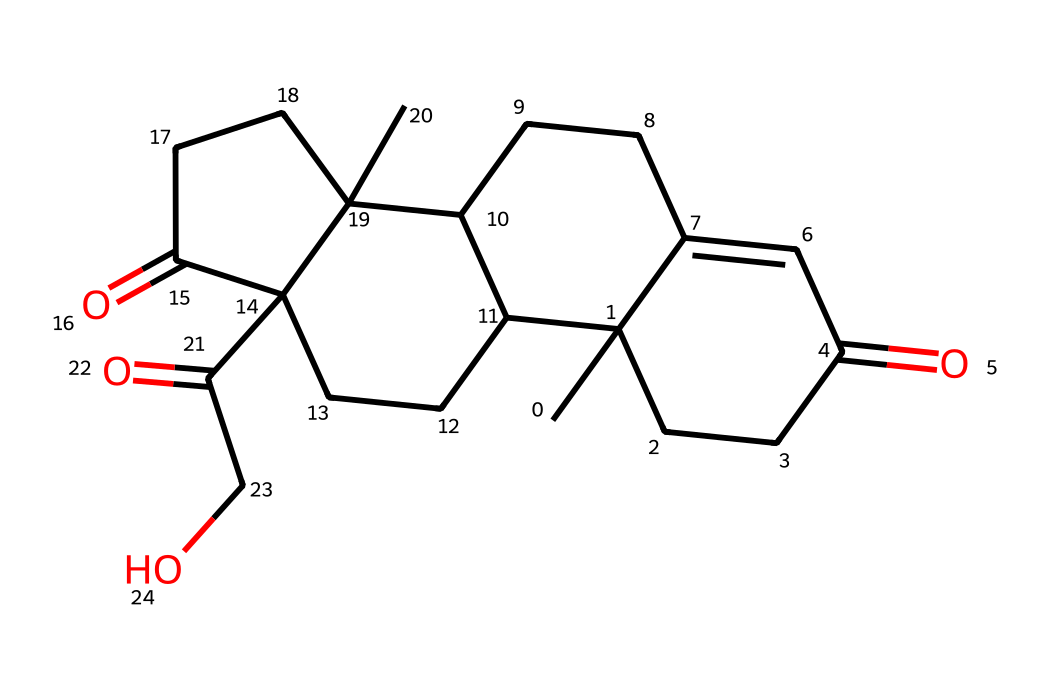How many carbon atoms are in cortisol? By analyzing the SMILES representation, we can count the number of carbon atoms by identifying the 'C' symbols. In this case, there are 21 carbon atoms.
Answer: 21 What is the functional group present in cortisol? Looking at the structure, we see that cortisol contains ketone groups, indicated by the C(=O) notation, as well as a hydroxyl group (–OH).
Answer: ketone, hydroxyl What is the molecular formula of cortisol? To determine the molecular formula, we count the number of each type of atom indicated in the SMILES: 21 carbons, 30 hydrogens, and 5 oxygens. This gives us the formula C21H30O5.
Answer: C21H30O5 How many double bonds are present in cortisol? By examining the SMILES, we can identify double bonds by locating the '=' symbols. There are 3 double bonds in the structure.
Answer: 3 Which type of stereochemistry is present in cortisol? The presence of multiple rings and substituents in the structure suggests that cortisol has stereogenic centers, indicating the presence of chirality in its configuration.
Answer: chirality What role does cortisol play in the human body? Cortisol is primarily known as the "stress hormone," which is involved in various physiological processes including metabolism and the immune response.
Answer: stress hormone Does cortisol contain any hypervalent atoms? In the context of hypervalent compounds, we look for atoms like phosphorus or sulfur capable of expanding their valence shell. However, cortisol does not have these elements, as it consists mainly of carbon, hydrogen, and oxygen.
Answer: no 